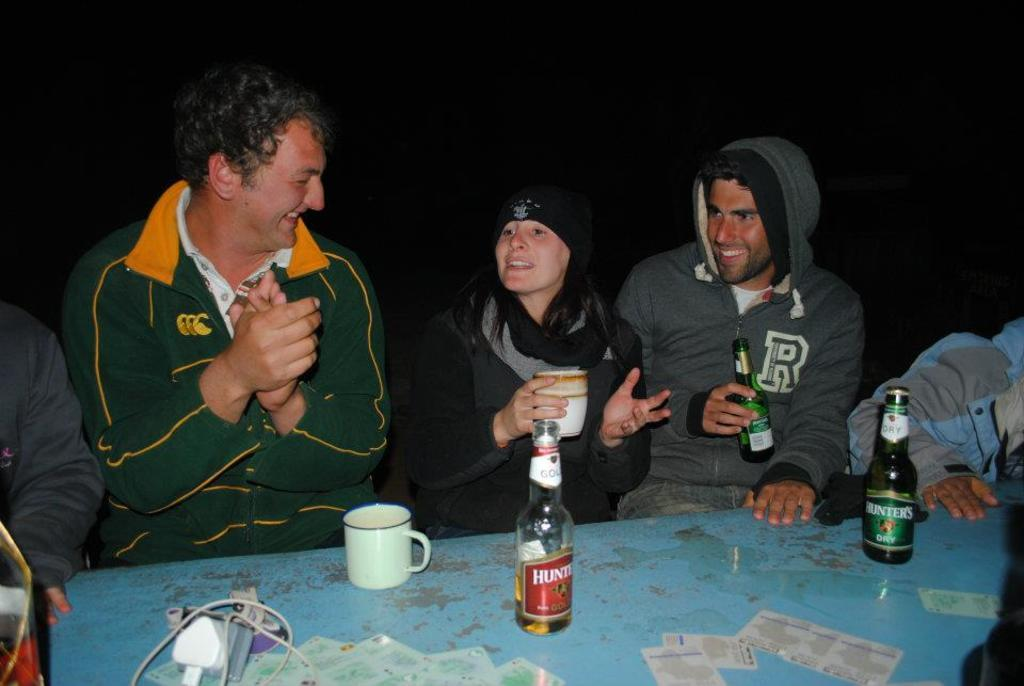What are the people in the image doing? The persons in the image are sitting on chairs around a table. What can be seen on the table in the image? There is a wine bottle, a mug, and a charger on the table. What is the mood of the people in the image? The persons in the image are smiling, which suggests a positive mood. What type of silk fabric is draped over the achiever's shoulders in the image? There is no achiever or silk fabric present in the image. What type of air currents can be seen affecting the objects in the image? There are no air currents visible in the image; the objects are stationary on the table. 